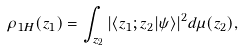<formula> <loc_0><loc_0><loc_500><loc_500>\rho _ { 1 H } ( z _ { 1 } ) = \int _ { z _ { 2 } } | \langle z _ { 1 } ; z _ { 2 } | \psi \rangle | ^ { 2 } d \mu ( z _ { 2 } ) ,</formula> 